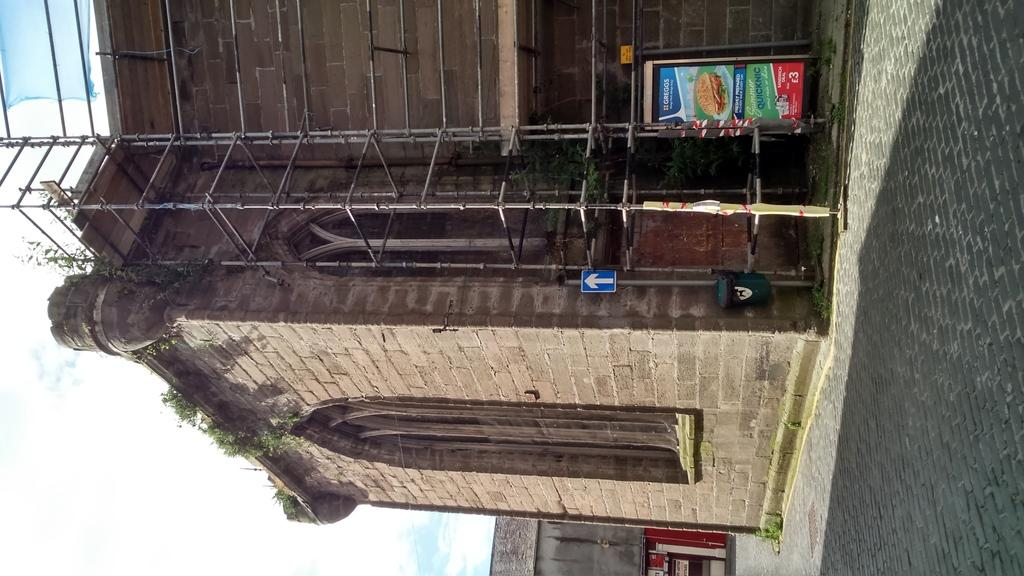How is the orientation of the image? The image is tilted. What can be seen on the right side of the image? There is a pavement on the right side of the image. What structure is located at the top of the image? There is a building at the top of the image. What part of the sky is visible in the image? The sky is visible in the bottom left of the image. What type of thrill can be experienced by the building in the image? The building in the image is not capable of experiencing any type of thrill, as it is an inanimate object. What material is the patch used to fix the pavement in the image? There is no patch visible in the image, as the pavement appears to be in good condition. 